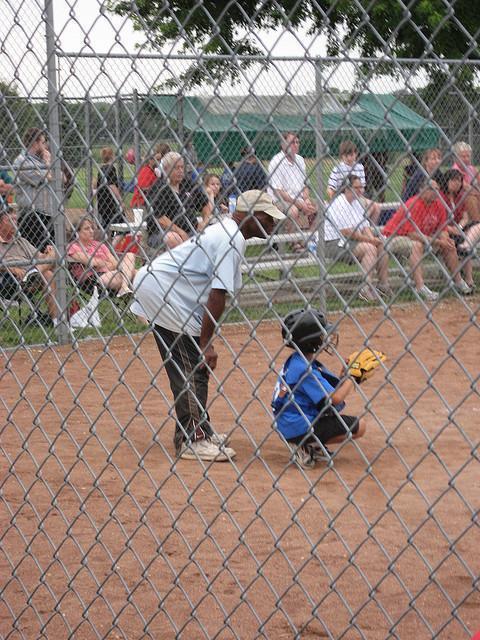How are the people in the stands here likely related to the players on the field here?
Indicate the correct response and explain using: 'Answer: answer
Rationale: rationale.'
Options: Unrelated fans, passersby, relatives, enemies. Answer: relatives.
Rationale: The people in the stand are most likely relatives watching their kids play. there may also be some family friends there who have come out to root for the kids. 